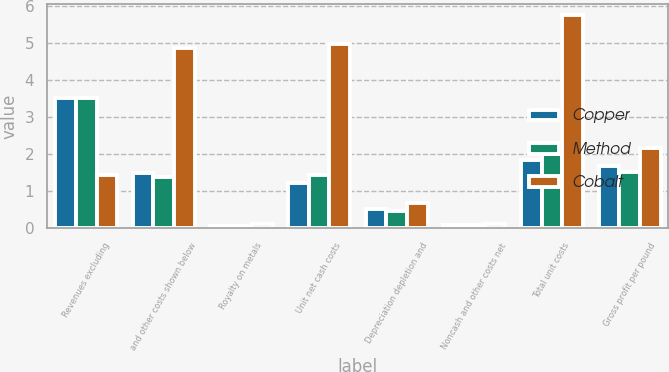Convert chart to OTSL. <chart><loc_0><loc_0><loc_500><loc_500><stacked_bar_chart><ecel><fcel>Revenues excluding<fcel>and other costs shown below<fcel>Royalty on metals<fcel>Unit net cash costs<fcel>Depreciation depletion and<fcel>Noncash and other costs net<fcel>Total unit costs<fcel>Gross profit per pound<nl><fcel>Copper<fcel>3.51<fcel>1.49<fcel>0.07<fcel>1.23<fcel>0.52<fcel>0.09<fcel>1.84<fcel>1.69<nl><fcel>Method<fcel>3.51<fcel>1.39<fcel>0.06<fcel>1.45<fcel>0.47<fcel>0.08<fcel>2<fcel>1.53<nl><fcel>Cobalt<fcel>1.45<fcel>4.86<fcel>0.12<fcel>4.98<fcel>0.67<fcel>0.11<fcel>5.76<fcel>2.16<nl></chart> 